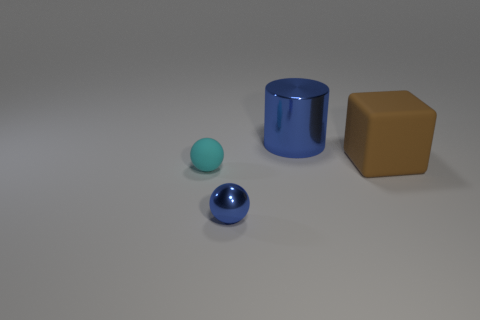Add 1 tiny things. How many objects exist? 5 Add 4 brown blocks. How many brown blocks exist? 5 Subtract 0 red cylinders. How many objects are left? 4 Subtract all matte spheres. Subtract all brown cubes. How many objects are left? 2 Add 4 large rubber objects. How many large rubber objects are left? 5 